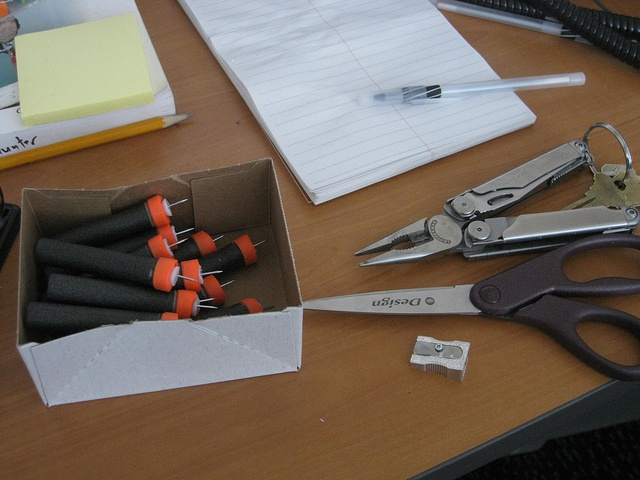Describe the objects in this image and their specific colors. I can see dining table in brown, black, darkgray, gray, and maroon tones, book in brown, lightgray, and darkgray tones, scissors in brown, black, maroon, and gray tones, and book in brown, beige, and tan tones in this image. 